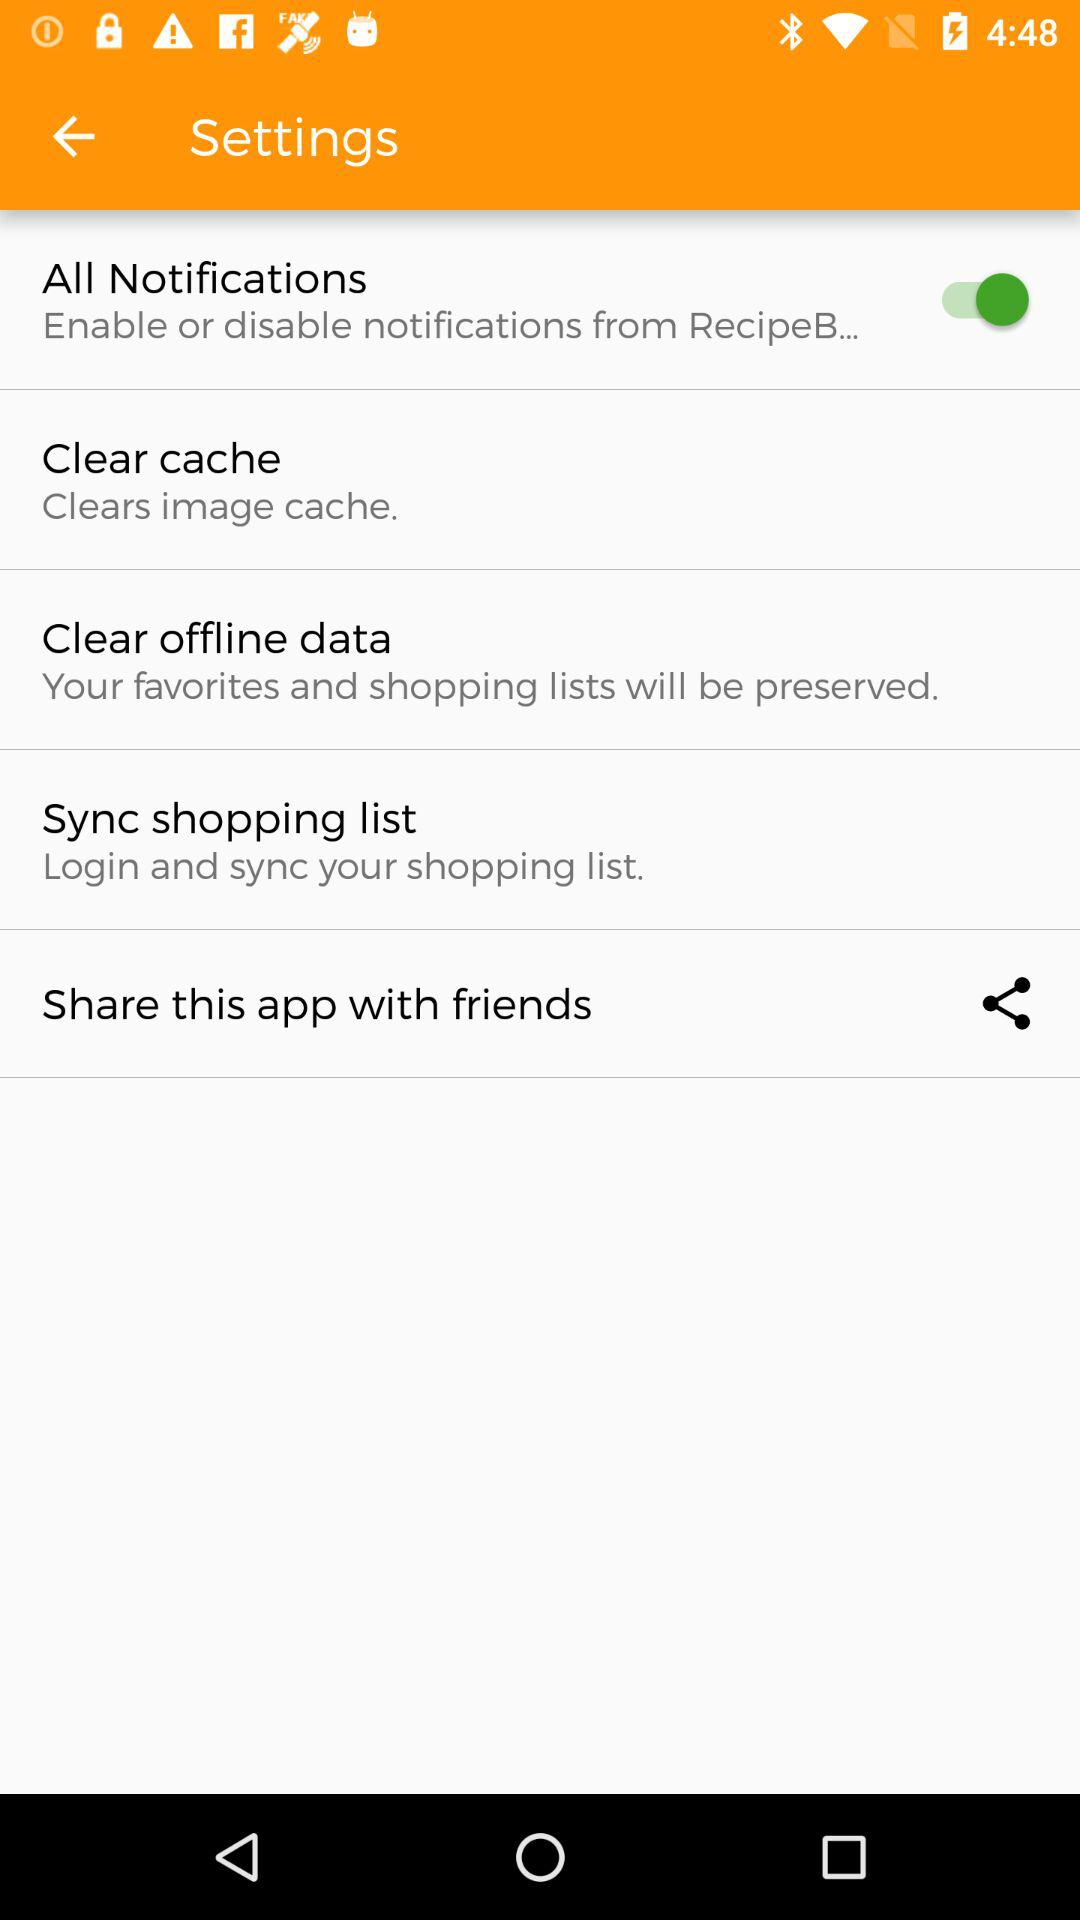How many items are in the settings menu?
Answer the question using a single word or phrase. 5 